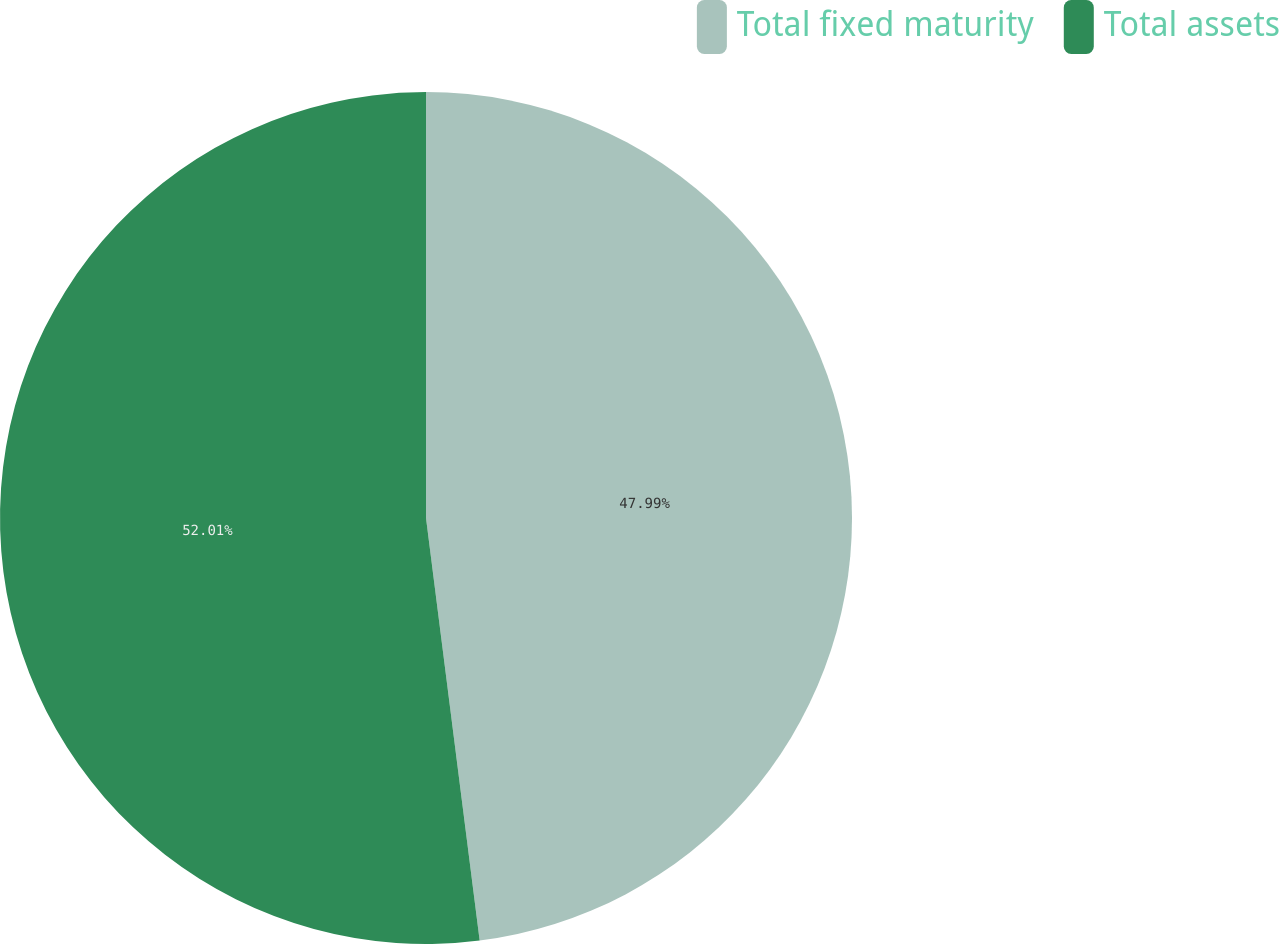<chart> <loc_0><loc_0><loc_500><loc_500><pie_chart><fcel>Total fixed maturity<fcel>Total assets<nl><fcel>47.99%<fcel>52.01%<nl></chart> 